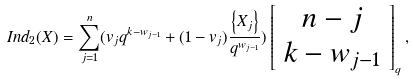<formula> <loc_0><loc_0><loc_500><loc_500>I n d _ { 2 } ( X ) = \sum _ { j = 1 } ^ { n } ( v _ { j } q ^ { k - w _ { j - 1 } } + ( 1 - v _ { j } ) \frac { \left \{ X _ { j } \right \} } { q ^ { w _ { j - 1 } } } ) \left [ \begin{array} { c } n - j \\ k - w _ { j - 1 } \end{array} \right ] _ { q } ,</formula> 